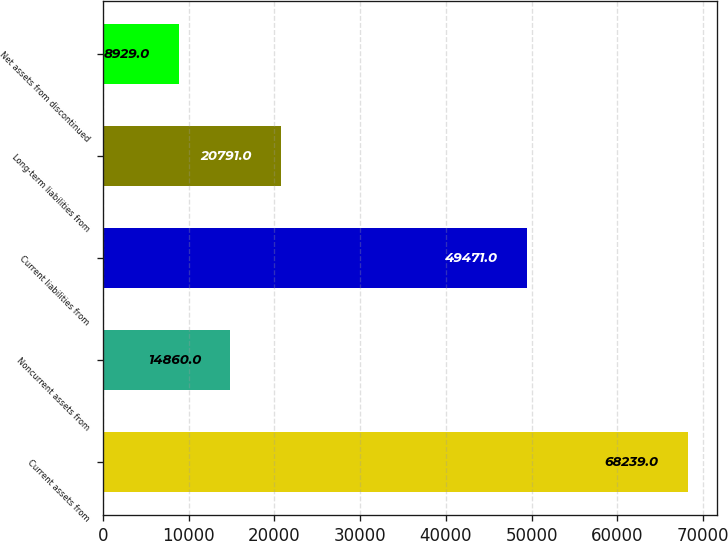Convert chart to OTSL. <chart><loc_0><loc_0><loc_500><loc_500><bar_chart><fcel>Current assets from<fcel>Noncurrent assets from<fcel>Current liabilities from<fcel>Long-term liabilities from<fcel>Net assets from discontinued<nl><fcel>68239<fcel>14860<fcel>49471<fcel>20791<fcel>8929<nl></chart> 